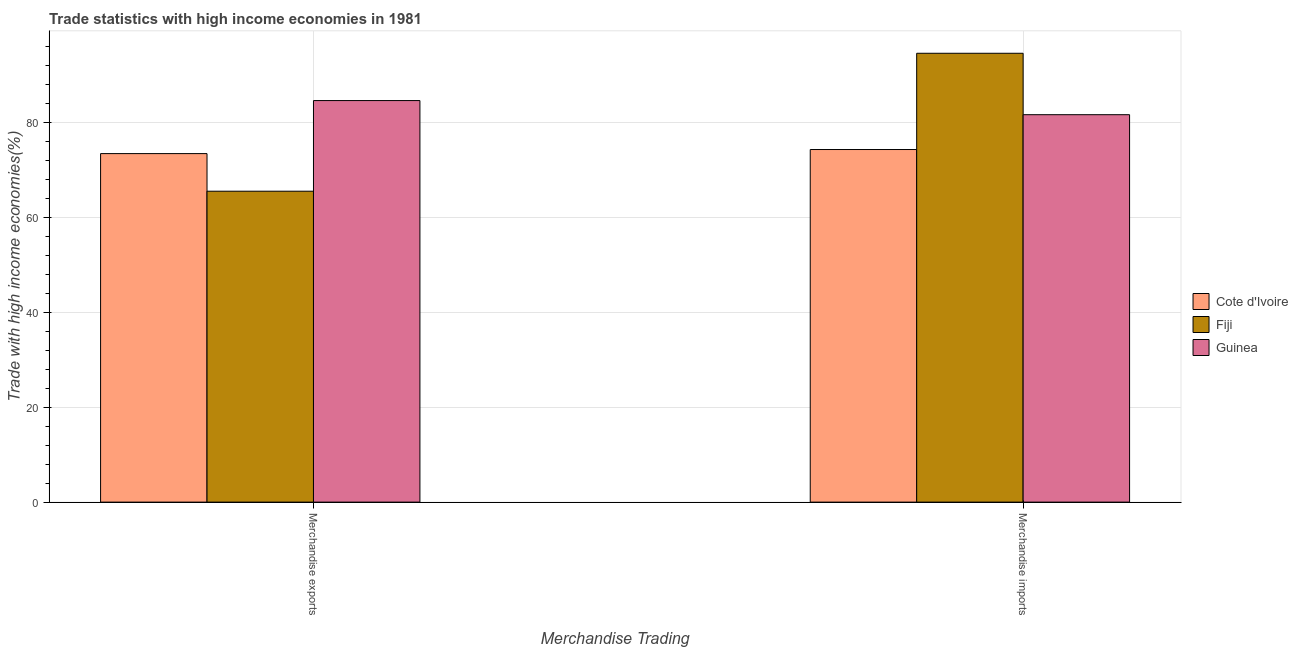How many groups of bars are there?
Offer a terse response. 2. Are the number of bars per tick equal to the number of legend labels?
Provide a short and direct response. Yes. How many bars are there on the 2nd tick from the right?
Your response must be concise. 3. What is the label of the 1st group of bars from the left?
Your response must be concise. Merchandise exports. What is the merchandise exports in Cote d'Ivoire?
Keep it short and to the point. 73.49. Across all countries, what is the maximum merchandise imports?
Give a very brief answer. 94.65. Across all countries, what is the minimum merchandise exports?
Your answer should be compact. 65.57. In which country was the merchandise exports maximum?
Offer a terse response. Guinea. In which country was the merchandise imports minimum?
Keep it short and to the point. Cote d'Ivoire. What is the total merchandise imports in the graph?
Your answer should be compact. 250.71. What is the difference between the merchandise imports in Guinea and that in Cote d'Ivoire?
Give a very brief answer. 7.35. What is the difference between the merchandise imports in Fiji and the merchandise exports in Cote d'Ivoire?
Your answer should be compact. 21.16. What is the average merchandise exports per country?
Your answer should be compact. 74.58. What is the difference between the merchandise imports and merchandise exports in Cote d'Ivoire?
Provide a succinct answer. 0.86. In how many countries, is the merchandise exports greater than 64 %?
Give a very brief answer. 3. What is the ratio of the merchandise imports in Cote d'Ivoire to that in Guinea?
Offer a very short reply. 0.91. What does the 2nd bar from the left in Merchandise imports represents?
Your answer should be compact. Fiji. What does the 3rd bar from the right in Merchandise exports represents?
Your response must be concise. Cote d'Ivoire. How many countries are there in the graph?
Your answer should be very brief. 3. What is the difference between two consecutive major ticks on the Y-axis?
Offer a very short reply. 20. Does the graph contain any zero values?
Give a very brief answer. No. Does the graph contain grids?
Your response must be concise. Yes. Where does the legend appear in the graph?
Keep it short and to the point. Center right. What is the title of the graph?
Give a very brief answer. Trade statistics with high income economies in 1981. What is the label or title of the X-axis?
Provide a succinct answer. Merchandise Trading. What is the label or title of the Y-axis?
Give a very brief answer. Trade with high income economies(%). What is the Trade with high income economies(%) of Cote d'Ivoire in Merchandise exports?
Give a very brief answer. 73.49. What is the Trade with high income economies(%) of Fiji in Merchandise exports?
Your answer should be very brief. 65.57. What is the Trade with high income economies(%) of Guinea in Merchandise exports?
Provide a succinct answer. 84.68. What is the Trade with high income economies(%) in Cote d'Ivoire in Merchandise imports?
Your response must be concise. 74.35. What is the Trade with high income economies(%) in Fiji in Merchandise imports?
Give a very brief answer. 94.65. What is the Trade with high income economies(%) in Guinea in Merchandise imports?
Keep it short and to the point. 81.7. Across all Merchandise Trading, what is the maximum Trade with high income economies(%) of Cote d'Ivoire?
Give a very brief answer. 74.35. Across all Merchandise Trading, what is the maximum Trade with high income economies(%) in Fiji?
Provide a short and direct response. 94.65. Across all Merchandise Trading, what is the maximum Trade with high income economies(%) of Guinea?
Provide a succinct answer. 84.68. Across all Merchandise Trading, what is the minimum Trade with high income economies(%) in Cote d'Ivoire?
Your answer should be very brief. 73.49. Across all Merchandise Trading, what is the minimum Trade with high income economies(%) of Fiji?
Offer a terse response. 65.57. Across all Merchandise Trading, what is the minimum Trade with high income economies(%) in Guinea?
Offer a very short reply. 81.7. What is the total Trade with high income economies(%) of Cote d'Ivoire in the graph?
Ensure brevity in your answer.  147.85. What is the total Trade with high income economies(%) of Fiji in the graph?
Provide a succinct answer. 160.22. What is the total Trade with high income economies(%) of Guinea in the graph?
Your answer should be compact. 166.38. What is the difference between the Trade with high income economies(%) of Cote d'Ivoire in Merchandise exports and that in Merchandise imports?
Provide a short and direct response. -0.86. What is the difference between the Trade with high income economies(%) of Fiji in Merchandise exports and that in Merchandise imports?
Provide a short and direct response. -29.09. What is the difference between the Trade with high income economies(%) in Guinea in Merchandise exports and that in Merchandise imports?
Offer a very short reply. 2.98. What is the difference between the Trade with high income economies(%) in Cote d'Ivoire in Merchandise exports and the Trade with high income economies(%) in Fiji in Merchandise imports?
Make the answer very short. -21.16. What is the difference between the Trade with high income economies(%) in Cote d'Ivoire in Merchandise exports and the Trade with high income economies(%) in Guinea in Merchandise imports?
Provide a succinct answer. -8.21. What is the difference between the Trade with high income economies(%) of Fiji in Merchandise exports and the Trade with high income economies(%) of Guinea in Merchandise imports?
Your answer should be compact. -16.14. What is the average Trade with high income economies(%) in Cote d'Ivoire per Merchandise Trading?
Ensure brevity in your answer.  73.92. What is the average Trade with high income economies(%) in Fiji per Merchandise Trading?
Your answer should be very brief. 80.11. What is the average Trade with high income economies(%) in Guinea per Merchandise Trading?
Keep it short and to the point. 83.19. What is the difference between the Trade with high income economies(%) of Cote d'Ivoire and Trade with high income economies(%) of Fiji in Merchandise exports?
Ensure brevity in your answer.  7.93. What is the difference between the Trade with high income economies(%) in Cote d'Ivoire and Trade with high income economies(%) in Guinea in Merchandise exports?
Make the answer very short. -11.18. What is the difference between the Trade with high income economies(%) in Fiji and Trade with high income economies(%) in Guinea in Merchandise exports?
Keep it short and to the point. -19.11. What is the difference between the Trade with high income economies(%) in Cote d'Ivoire and Trade with high income economies(%) in Fiji in Merchandise imports?
Provide a short and direct response. -20.3. What is the difference between the Trade with high income economies(%) in Cote d'Ivoire and Trade with high income economies(%) in Guinea in Merchandise imports?
Keep it short and to the point. -7.35. What is the difference between the Trade with high income economies(%) in Fiji and Trade with high income economies(%) in Guinea in Merchandise imports?
Offer a very short reply. 12.95. What is the ratio of the Trade with high income economies(%) in Cote d'Ivoire in Merchandise exports to that in Merchandise imports?
Your answer should be compact. 0.99. What is the ratio of the Trade with high income economies(%) in Fiji in Merchandise exports to that in Merchandise imports?
Your response must be concise. 0.69. What is the ratio of the Trade with high income economies(%) in Guinea in Merchandise exports to that in Merchandise imports?
Your response must be concise. 1.04. What is the difference between the highest and the second highest Trade with high income economies(%) of Cote d'Ivoire?
Give a very brief answer. 0.86. What is the difference between the highest and the second highest Trade with high income economies(%) in Fiji?
Your answer should be very brief. 29.09. What is the difference between the highest and the second highest Trade with high income economies(%) of Guinea?
Ensure brevity in your answer.  2.98. What is the difference between the highest and the lowest Trade with high income economies(%) of Cote d'Ivoire?
Give a very brief answer. 0.86. What is the difference between the highest and the lowest Trade with high income economies(%) of Fiji?
Keep it short and to the point. 29.09. What is the difference between the highest and the lowest Trade with high income economies(%) of Guinea?
Your answer should be very brief. 2.98. 